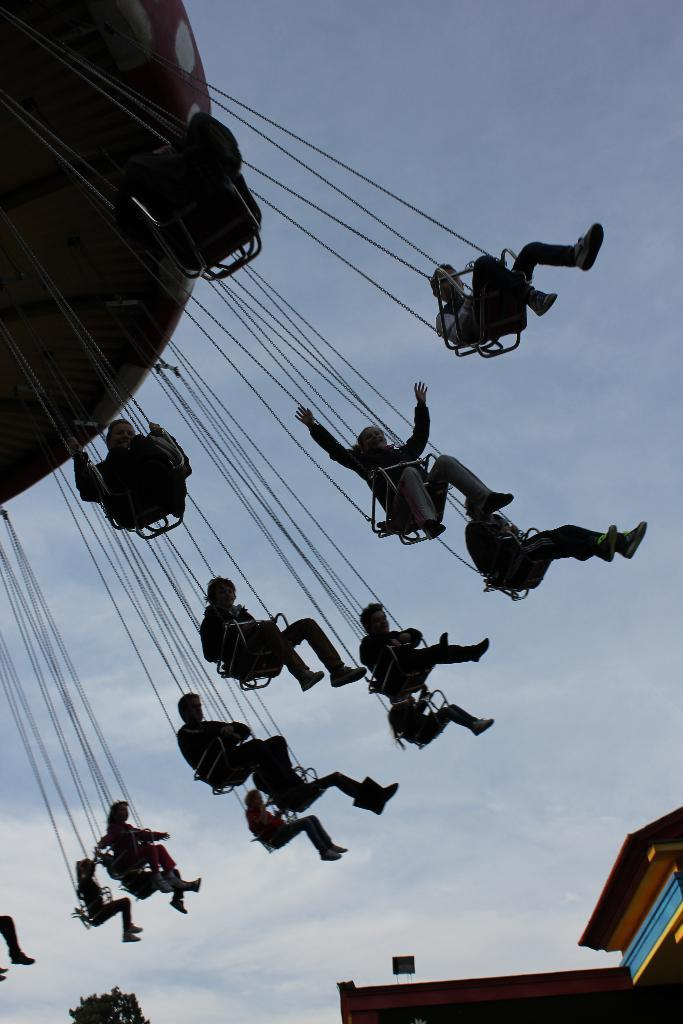What is happening in the image involving the people? The people are playing a ride. How are the people positioned during this activity? The people are sitting on seats. What can be seen in the background of the image? There is a sky visible in the background of the image. What is present at the bottom of the image? There is a tree and a wall at the bottom of the image. What type of straw is being used to stir the soup in the image? There is no straw or soup present in the image. 